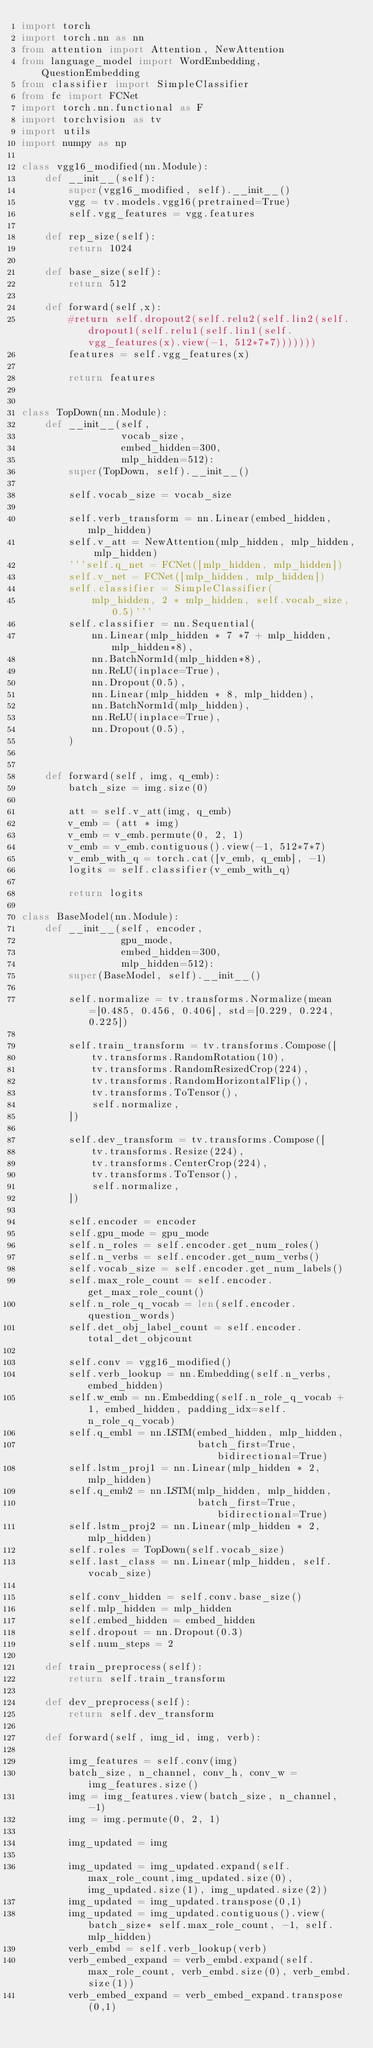Convert code to text. <code><loc_0><loc_0><loc_500><loc_500><_Python_>import torch
import torch.nn as nn
from attention import Attention, NewAttention
from language_model import WordEmbedding, QuestionEmbedding
from classifier import SimpleClassifier
from fc import FCNet
import torch.nn.functional as F
import torchvision as tv
import utils
import numpy as np

class vgg16_modified(nn.Module):
    def __init__(self):
        super(vgg16_modified, self).__init__()
        vgg = tv.models.vgg16(pretrained=True)
        self.vgg_features = vgg.features

    def rep_size(self):
        return 1024

    def base_size(self):
        return 512

    def forward(self,x):
        #return self.dropout2(self.relu2(self.lin2(self.dropout1(self.relu1(self.lin1(self.vgg_features(x).view(-1, 512*7*7)))))))
        features = self.vgg_features(x)

        return features


class TopDown(nn.Module):
    def __init__(self,
                 vocab_size,
                 embed_hidden=300,
                 mlp_hidden=512):
        super(TopDown, self).__init__()

        self.vocab_size = vocab_size

        self.verb_transform = nn.Linear(embed_hidden, mlp_hidden)
        self.v_att = NewAttention(mlp_hidden, mlp_hidden, mlp_hidden)
        '''self.q_net = FCNet([mlp_hidden, mlp_hidden])
        self.v_net = FCNet([mlp_hidden, mlp_hidden])
        self.classifier = SimpleClassifier(
            mlp_hidden, 2 * mlp_hidden, self.vocab_size, 0.5)'''
        self.classifier = nn.Sequential(
            nn.Linear(mlp_hidden * 7 *7 + mlp_hidden, mlp_hidden*8),
            nn.BatchNorm1d(mlp_hidden*8),
            nn.ReLU(inplace=True),
            nn.Dropout(0.5),
            nn.Linear(mlp_hidden * 8, mlp_hidden),
            nn.BatchNorm1d(mlp_hidden),
            nn.ReLU(inplace=True),
            nn.Dropout(0.5),
        )


    def forward(self, img, q_emb):
        batch_size = img.size(0)

        att = self.v_att(img, q_emb)
        v_emb = (att * img)
        v_emb = v_emb.permute(0, 2, 1)
        v_emb = v_emb.contiguous().view(-1, 512*7*7)
        v_emb_with_q = torch.cat([v_emb, q_emb], -1)
        logits = self.classifier(v_emb_with_q)

        return logits

class BaseModel(nn.Module):
    def __init__(self, encoder,
                 gpu_mode,
                 embed_hidden=300,
                 mlp_hidden=512):
        super(BaseModel, self).__init__()

        self.normalize = tv.transforms.Normalize(mean=[0.485, 0.456, 0.406], std=[0.229, 0.224, 0.225])

        self.train_transform = tv.transforms.Compose([
            tv.transforms.RandomRotation(10),
            tv.transforms.RandomResizedCrop(224),
            tv.transforms.RandomHorizontalFlip(),
            tv.transforms.ToTensor(),
            self.normalize,
        ])

        self.dev_transform = tv.transforms.Compose([
            tv.transforms.Resize(224),
            tv.transforms.CenterCrop(224),
            tv.transforms.ToTensor(),
            self.normalize,
        ])

        self.encoder = encoder
        self.gpu_mode = gpu_mode
        self.n_roles = self.encoder.get_num_roles()
        self.n_verbs = self.encoder.get_num_verbs()
        self.vocab_size = self.encoder.get_num_labels()
        self.max_role_count = self.encoder.get_max_role_count()
        self.n_role_q_vocab = len(self.encoder.question_words)
        self.det_obj_label_count = self.encoder.total_det_objcount

        self.conv = vgg16_modified()
        self.verb_lookup = nn.Embedding(self.n_verbs, embed_hidden)
        self.w_emb = nn.Embedding(self.n_role_q_vocab + 1, embed_hidden, padding_idx=self.n_role_q_vocab)
        self.q_emb1 = nn.LSTM(embed_hidden, mlp_hidden,
                              batch_first=True, bidirectional=True)
        self.lstm_proj1 = nn.Linear(mlp_hidden * 2, mlp_hidden)
        self.q_emb2 = nn.LSTM(mlp_hidden, mlp_hidden,
                              batch_first=True, bidirectional=True)
        self.lstm_proj2 = nn.Linear(mlp_hidden * 2, mlp_hidden)
        self.roles = TopDown(self.vocab_size)
        self.last_class = nn.Linear(mlp_hidden, self.vocab_size)

        self.conv_hidden = self.conv.base_size()
        self.mlp_hidden = mlp_hidden
        self.embed_hidden = embed_hidden
        self.dropout = nn.Dropout(0.3)
        self.num_steps = 2

    def train_preprocess(self):
        return self.train_transform

    def dev_preprocess(self):
        return self.dev_transform

    def forward(self, img_id, img, verb):

        img_features = self.conv(img)
        batch_size, n_channel, conv_h, conv_w = img_features.size()
        img = img_features.view(batch_size, n_channel, -1)
        img = img.permute(0, 2, 1)

        img_updated = img

        img_updated = img_updated.expand(self.max_role_count,img_updated.size(0), img_updated.size(1), img_updated.size(2))
        img_updated = img_updated.transpose(0,1)
        img_updated = img_updated.contiguous().view(batch_size* self.max_role_count, -1, self.mlp_hidden)
        verb_embd = self.verb_lookup(verb)
        verb_embed_expand = verb_embd.expand(self.max_role_count, verb_embd.size(0), verb_embd.size(1))
        verb_embed_expand = verb_embed_expand.transpose(0,1)</code> 